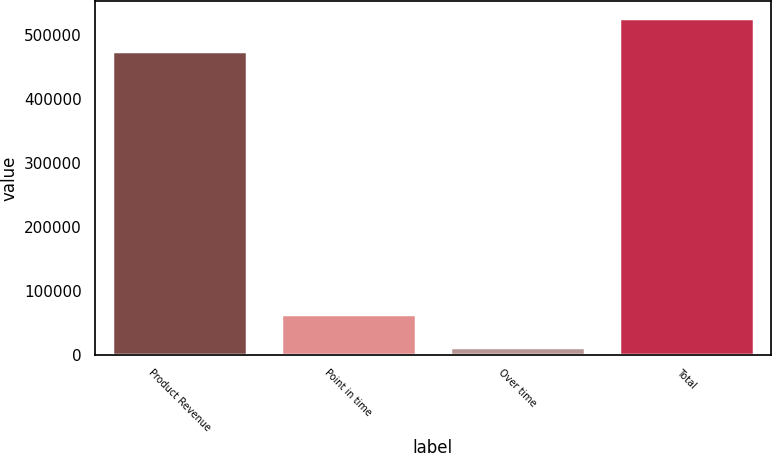Convert chart to OTSL. <chart><loc_0><loc_0><loc_500><loc_500><bar_chart><fcel>Product Revenue<fcel>Point in time<fcel>Over time<fcel>Total<nl><fcel>475025<fcel>62911.3<fcel>11556<fcel>526380<nl></chart> 